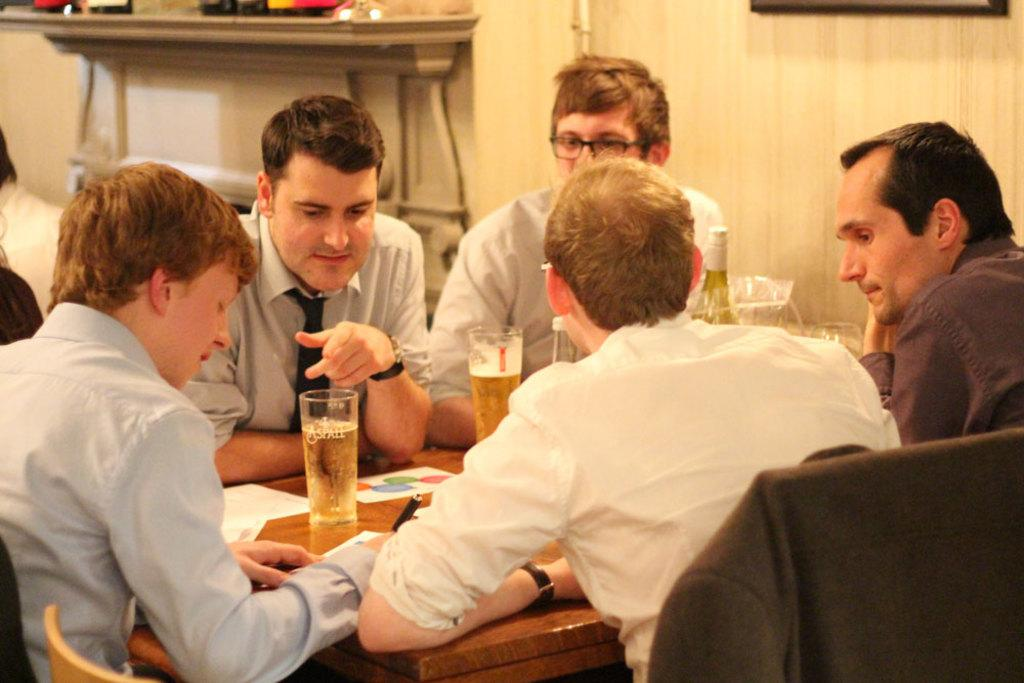How many people are in the image? There are five persons in the image. What are the persons doing in the image? The persons are sitting on chairs. How are the chairs arranged in the image? The chairs are arranged around a table. What can be seen on the table in the image? There are glasses with drinks, bottles, papers, and pens on the table. What type of kite is being flown by the persons in the image? There is no kite present in the image; the persons are sitting around a table. What is the reason for the protest in the image? There is no protest present in the image; the persons are sitting around a table with glasses, bottles, papers, and pens. 